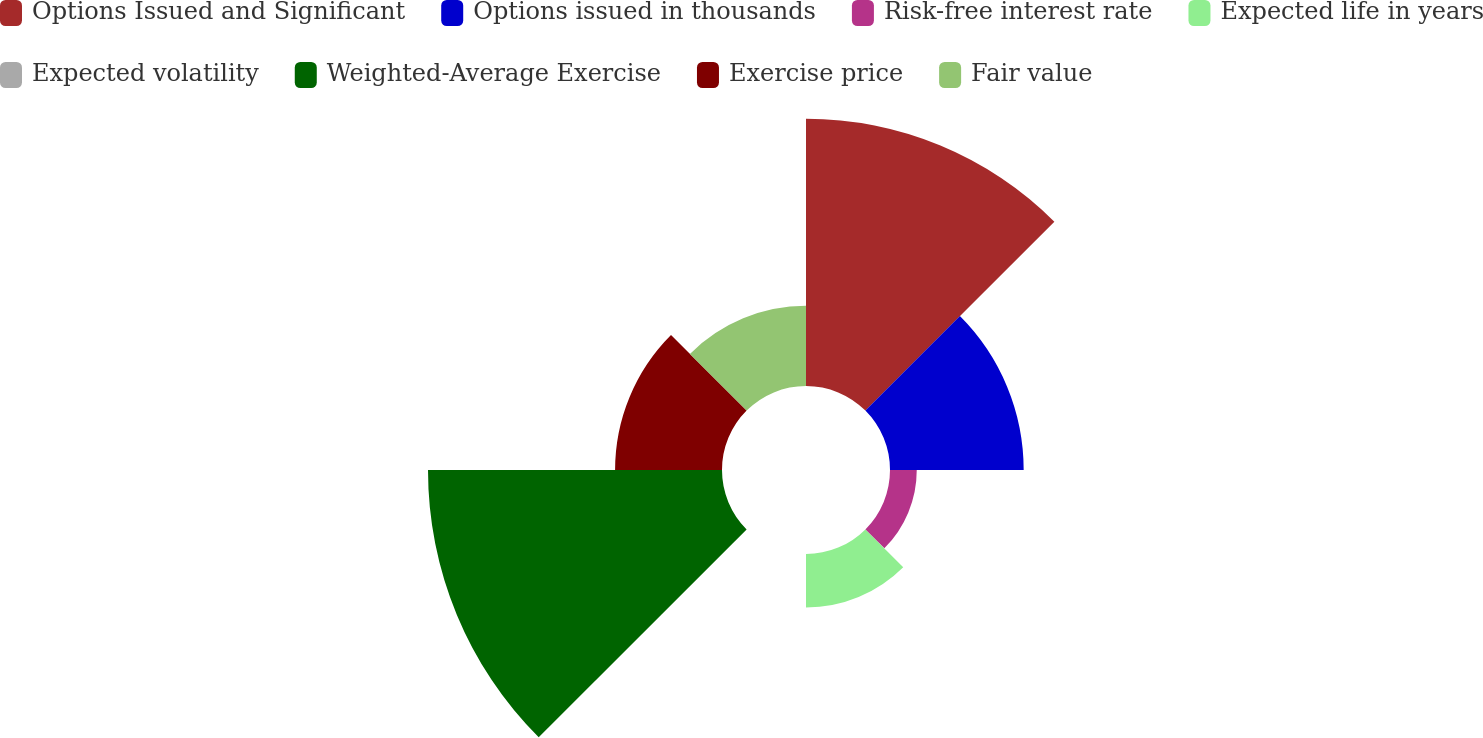Convert chart. <chart><loc_0><loc_0><loc_500><loc_500><pie_chart><fcel>Options Issued and Significant<fcel>Options issued in thousands<fcel>Risk-free interest rate<fcel>Expected life in years<fcel>Expected volatility<fcel>Weighted-Average Exercise<fcel>Exercise price<fcel>Fair value<nl><fcel>27.77%<fcel>13.89%<fcel>2.78%<fcel>5.56%<fcel>0.0%<fcel>30.55%<fcel>11.11%<fcel>8.33%<nl></chart> 